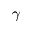<formula> <loc_0><loc_0><loc_500><loc_500>\gamma</formula> 